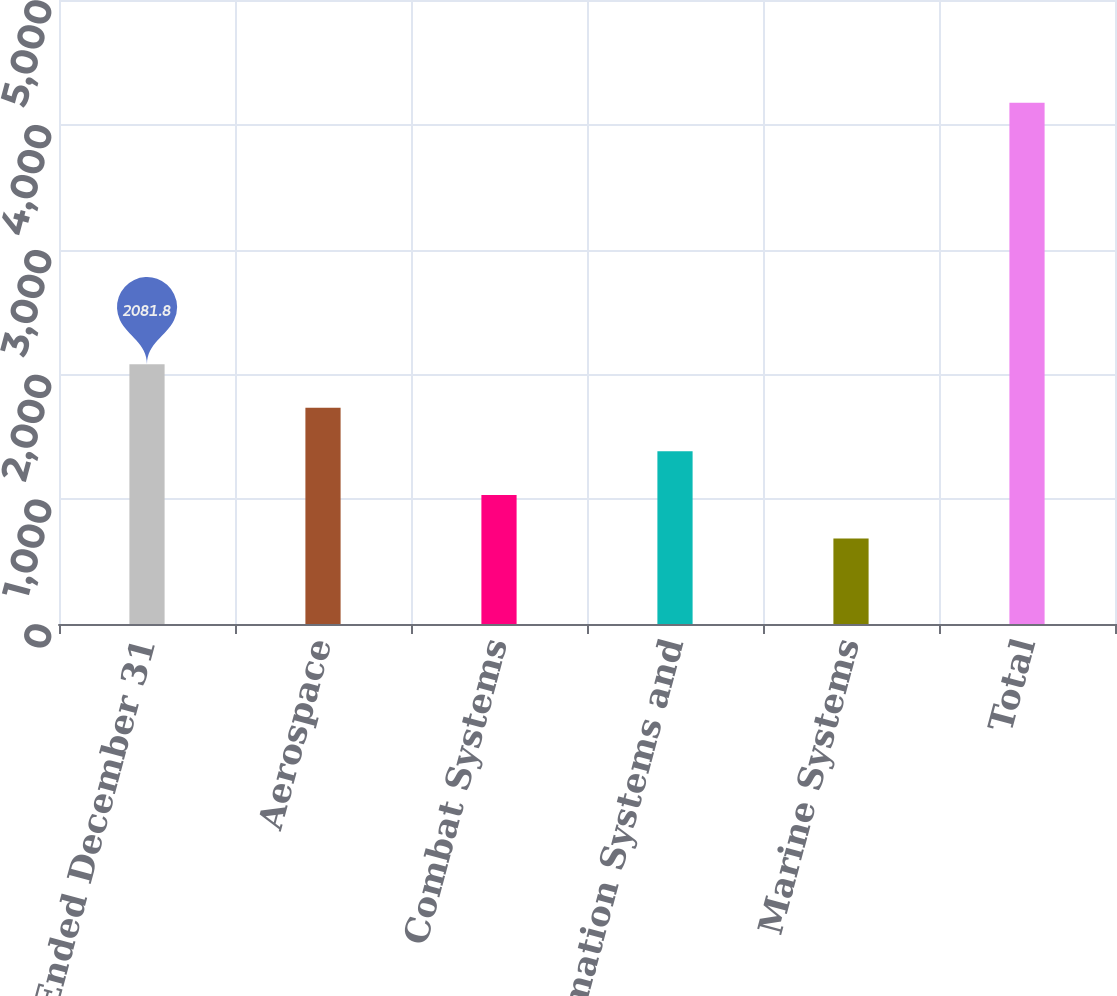<chart> <loc_0><loc_0><loc_500><loc_500><bar_chart><fcel>Year Ended December 31<fcel>Aerospace<fcel>Combat Systems<fcel>Information Systems and<fcel>Marine Systems<fcel>Total<nl><fcel>2081.8<fcel>1732.6<fcel>1034.2<fcel>1383.4<fcel>685<fcel>4177<nl></chart> 